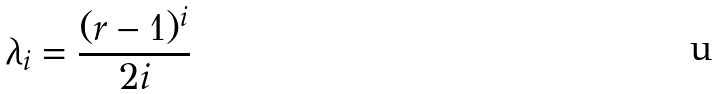<formula> <loc_0><loc_0><loc_500><loc_500>\lambda _ { i } = { \frac { ( r - 1 ) ^ { i } } { 2 i } }</formula> 